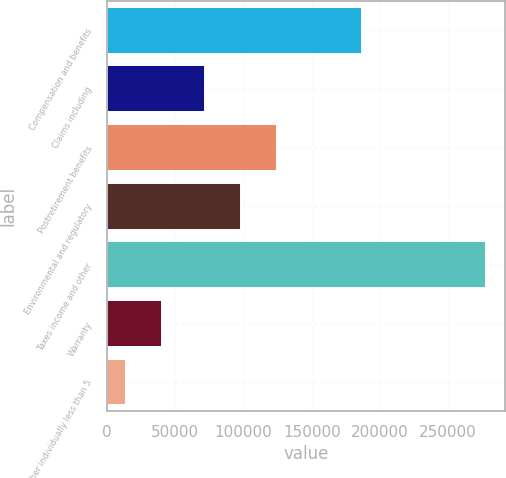<chart> <loc_0><loc_0><loc_500><loc_500><bar_chart><fcel>Compensation and benefits<fcel>Claims including<fcel>Postretirement benefits<fcel>Environmental and regulatory<fcel>Taxes income and other<fcel>Warranty<fcel>Other individually less than 5<nl><fcel>186523<fcel>71821<fcel>124645<fcel>98233.2<fcel>277652<fcel>39942.2<fcel>13530<nl></chart> 